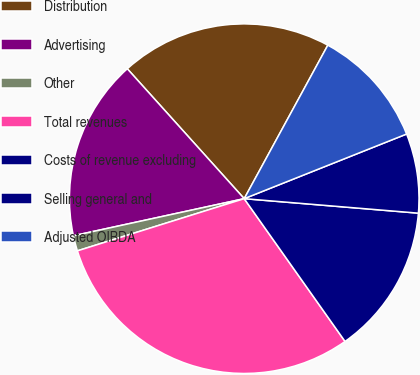Convert chart to OTSL. <chart><loc_0><loc_0><loc_500><loc_500><pie_chart><fcel>Distribution<fcel>Advertising<fcel>Other<fcel>Total revenues<fcel>Costs of revenue excluding<fcel>Selling general and<fcel>Adjusted OIBDA<nl><fcel>19.6%<fcel>16.74%<fcel>1.42%<fcel>29.96%<fcel>13.89%<fcel>7.35%<fcel>11.03%<nl></chart> 